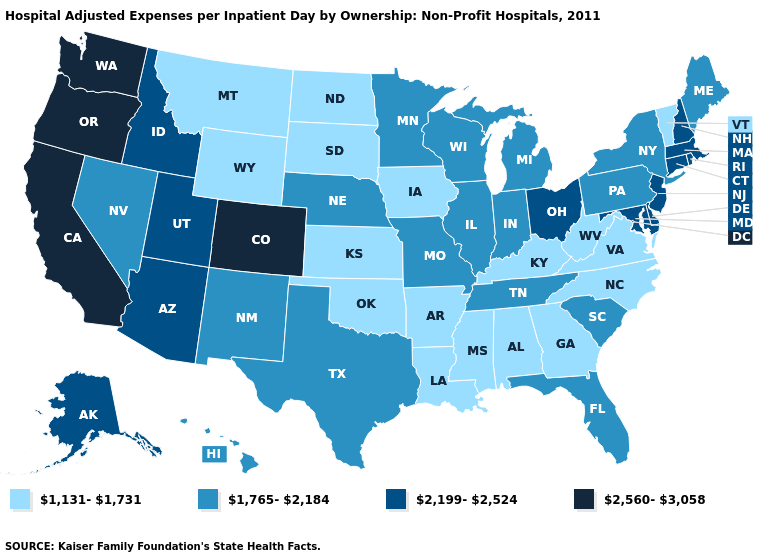What is the value of Missouri?
Be succinct. 1,765-2,184. Does Wyoming have the lowest value in the West?
Concise answer only. Yes. What is the value of Alaska?
Be succinct. 2,199-2,524. Is the legend a continuous bar?
Short answer required. No. Name the states that have a value in the range 1,131-1,731?
Answer briefly. Alabama, Arkansas, Georgia, Iowa, Kansas, Kentucky, Louisiana, Mississippi, Montana, North Carolina, North Dakota, Oklahoma, South Dakota, Vermont, Virginia, West Virginia, Wyoming. Name the states that have a value in the range 1,765-2,184?
Quick response, please. Florida, Hawaii, Illinois, Indiana, Maine, Michigan, Minnesota, Missouri, Nebraska, Nevada, New Mexico, New York, Pennsylvania, South Carolina, Tennessee, Texas, Wisconsin. Name the states that have a value in the range 2,560-3,058?
Write a very short answer. California, Colorado, Oregon, Washington. What is the highest value in states that border Colorado?
Short answer required. 2,199-2,524. Name the states that have a value in the range 2,560-3,058?
Be succinct. California, Colorado, Oregon, Washington. Which states hav the highest value in the MidWest?
Give a very brief answer. Ohio. Name the states that have a value in the range 2,560-3,058?
Answer briefly. California, Colorado, Oregon, Washington. Which states hav the highest value in the South?
Concise answer only. Delaware, Maryland. What is the lowest value in the USA?
Write a very short answer. 1,131-1,731. What is the value of Florida?
Write a very short answer. 1,765-2,184. Which states have the lowest value in the West?
Give a very brief answer. Montana, Wyoming. 